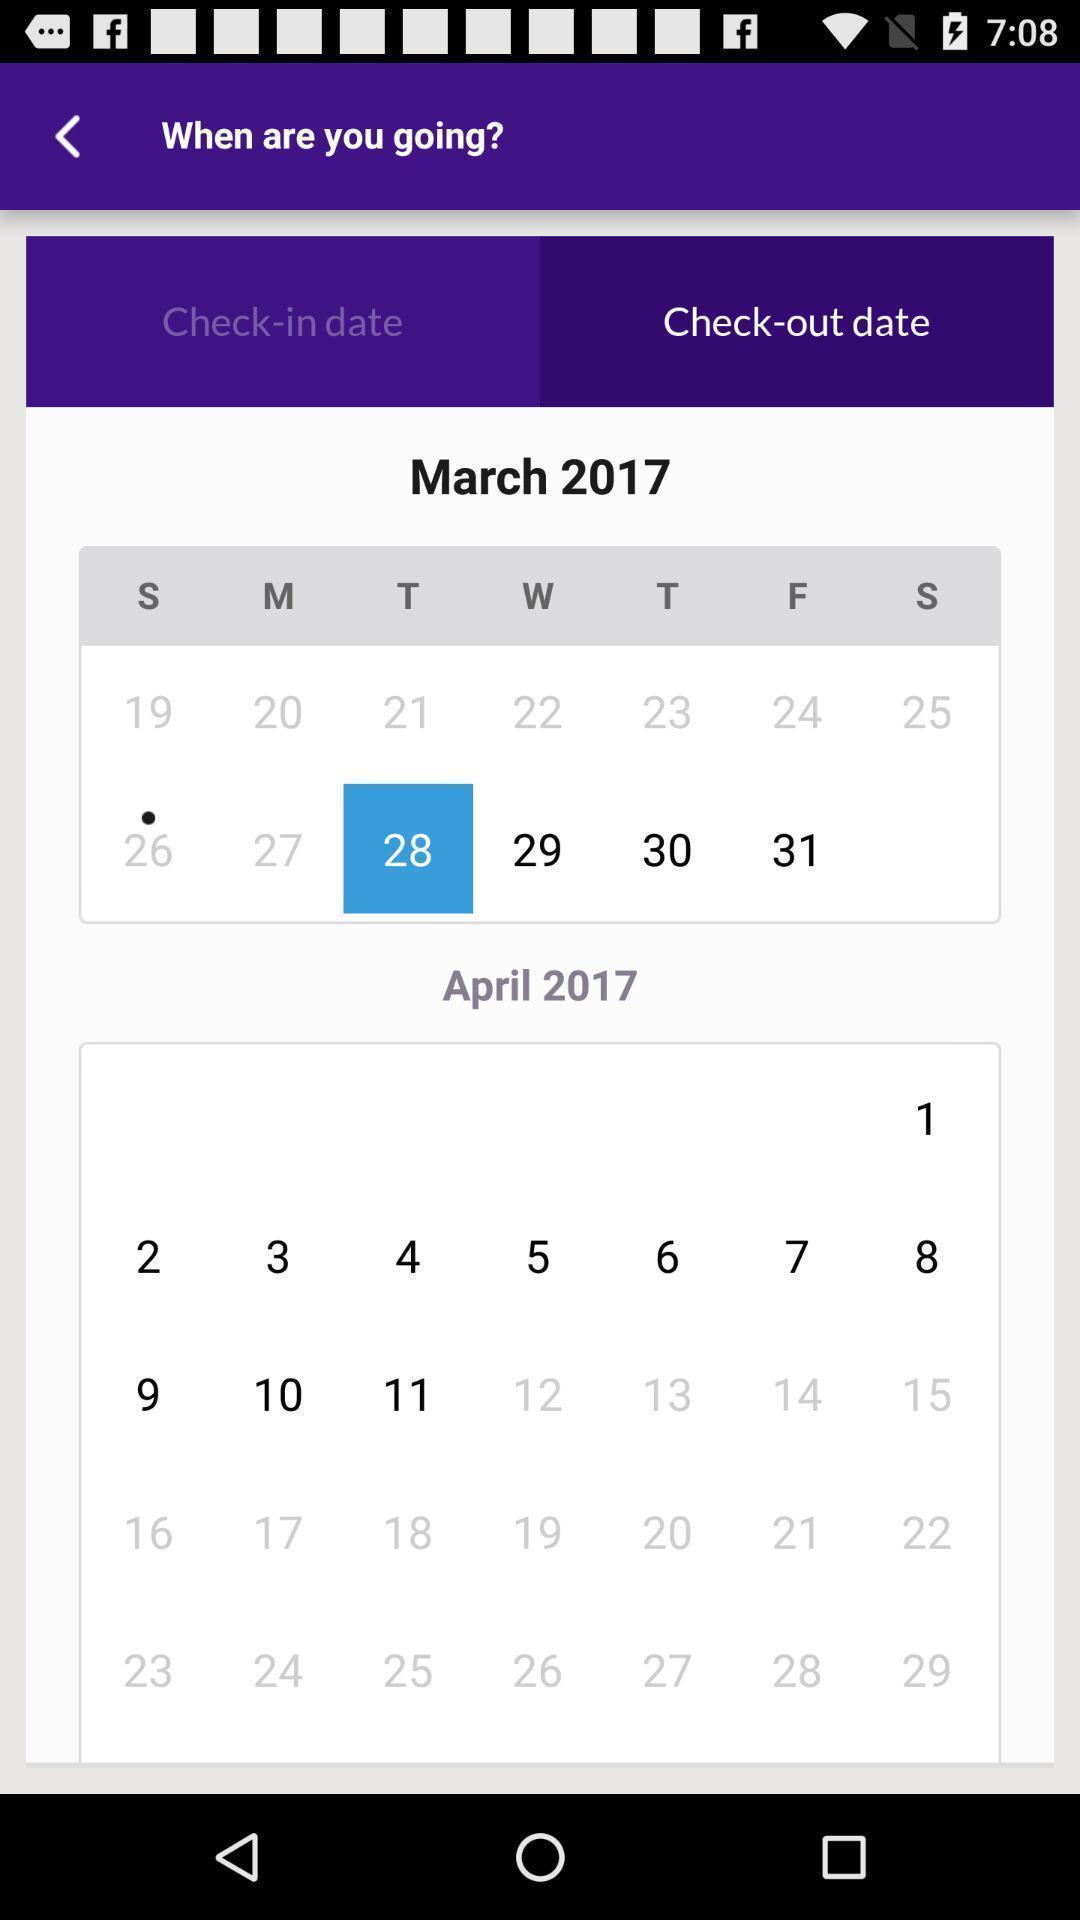What can you discern from this picture? Page displaying for booking tickets in hotel application. 